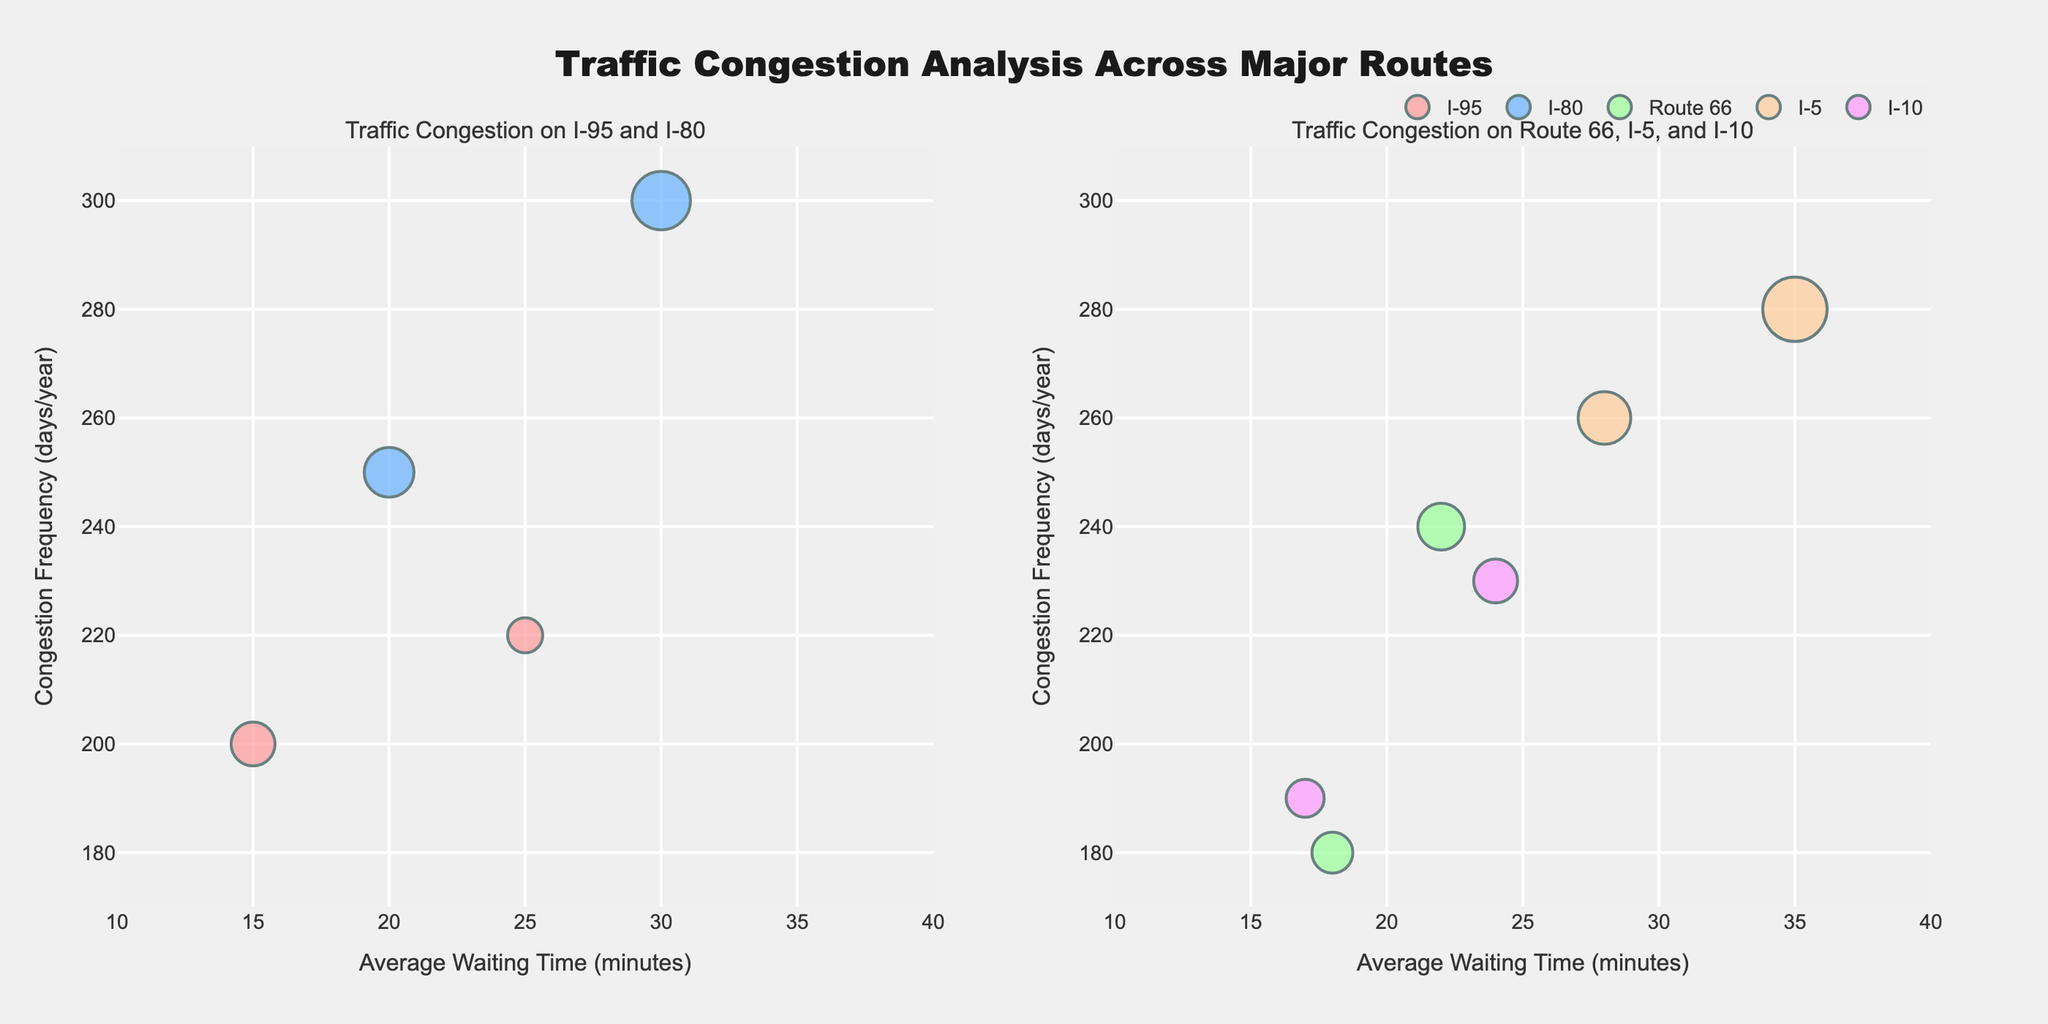what are the axes titles? The x-axis is titled "Average Waiting Time (minutes)" and the y-axis is titled "Congestion Frequency (days/year)" as shown in the figure.
Answer: "Average Waiting Time (minutes)" and "Congestion Frequency (days/year)" how many routes are visualized in the figure? The figure represents five different routes: I-95, I-80, Route 66, I-5, and I-10, as indicated by the legend.
Answer: five which location has the highest traffic volume? Looking at the bubble sizes, "Downtown Los Angeles" on I-5 has the largest bubble, which indicates the highest traffic volume.
Answer: Downtown Los Angeles which route has more locations with congestion data, I-95 or I-80? I-80 has two locations - "Philadelphia City Center" and "Lincoln Tunnel", while I-95 also has two locations - "Highway Intersection 12" and "Downtown Miami", so they have an equal number of locations.
Answer: equal what's the difference in congestion frequency between "Lincoln Tunnel" and "Downtown Chicago"? "Lincoln Tunnel" has a congestion frequency of 300 days/year, and "Downtown Chicago" has a frequency of 240 days/year, the difference is 60 days/year.
Answer: 60 days/year which route has bubbles with higher average waiting times, I-95 or I-80? Comparing the x-positions of the bubbles for I-95 and I-80, I-80 has one bubble at 20 and another at 30, while I-95 has bubbles at 15 and 25. The higher average waiting time on I-80 (average is 25) compared to I-95 (average is 20).
Answer: I-80 what is the average congestion frequency of "San Francisco Bridge" and "Downtown Los Angeles"? "San Francisco Bridge" has a congestion frequency of 260 days/year and "Downtown Los Angeles" has 280 days/year. The average is (260 + 280) / 2 = 270 days/year.
Answer: 270 days/year is traffic congestion worse in "Downtown Los Angeles" or "New Orleans Exit"? "Downtown Los Angeles" has an average waiting time of 35 minutes and congestion frequency of 280 days/year, which is worse compared to "New Orleans Exit" with 17 minutes average waiting time and 190 days/year congestion frequency.
Answer: Downtown Los Angeles which subplot contains the route "I-10"? The "I-10" route is visualized in the right subplot titled "Traffic Congestion on Route 66, I-5, and I-10".
Answer: right subplot 